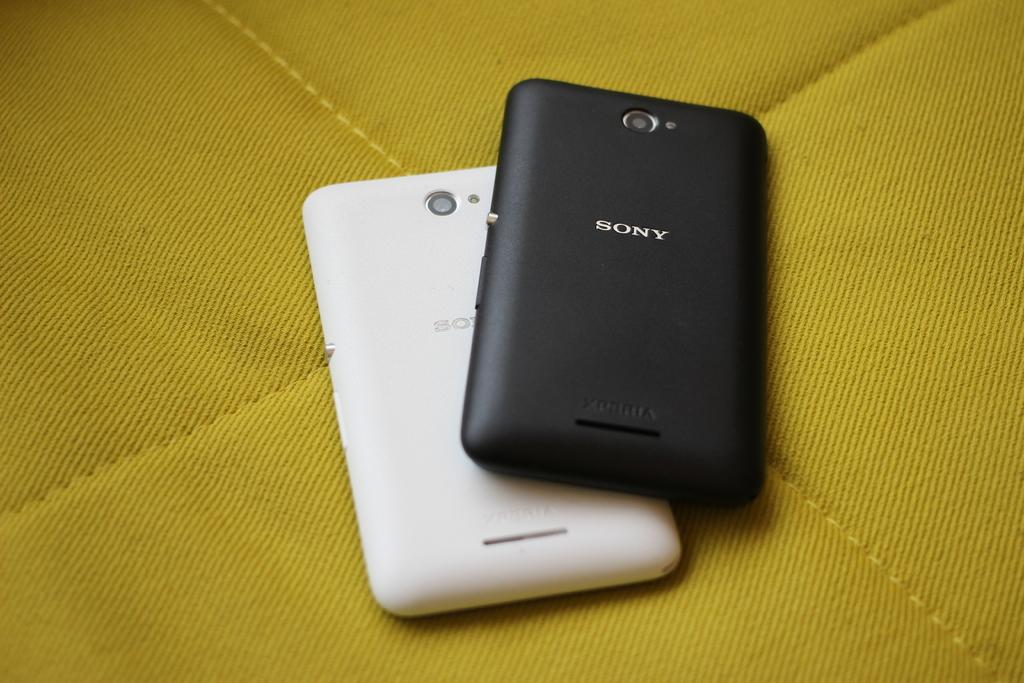<image>
Share a concise interpretation of the image provided. Two Sony branded phones in black and white on a yellow sheet. 